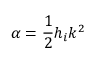Convert formula to latex. <formula><loc_0><loc_0><loc_500><loc_500>\alpha = \frac { 1 } { 2 } h _ { i } k ^ { 2 }</formula> 